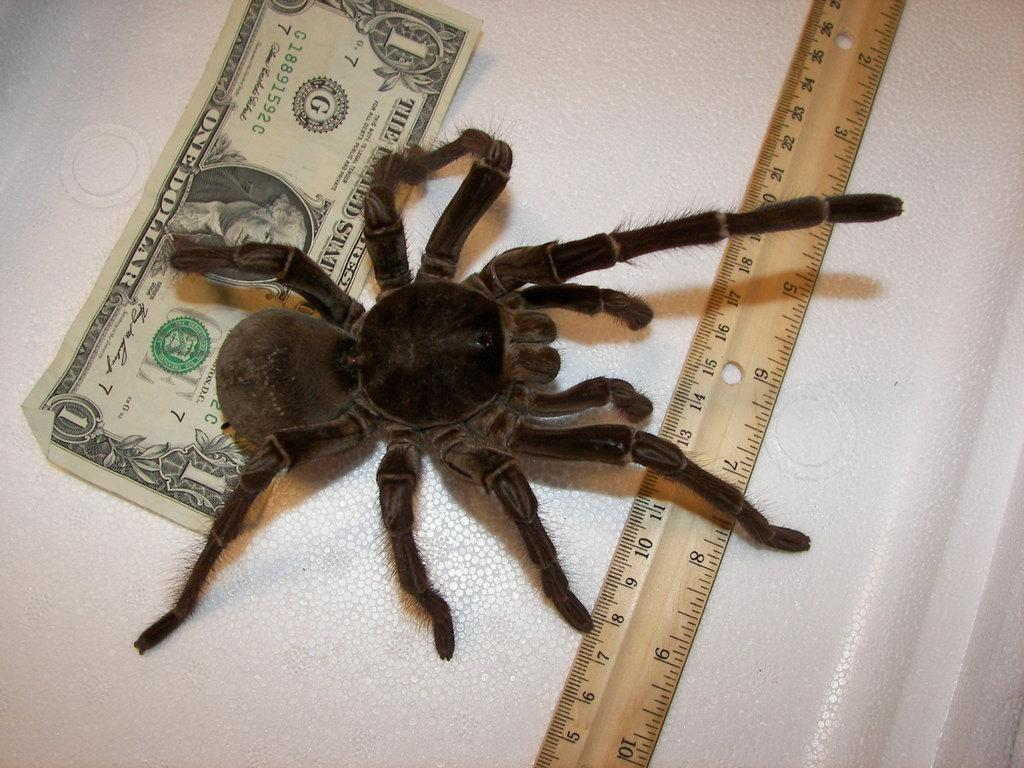What is the color of the spider in the image? The spider in the image is black. What can be used to measure weight in the image? There is a scale in the image. What type of currency is present in the image? There is a dollar note in the image. What is the color of the surface in the image? The surface in the image is white. What language is spoken by the spider in the image? There is no indication that the spider can speak any language in the image. 